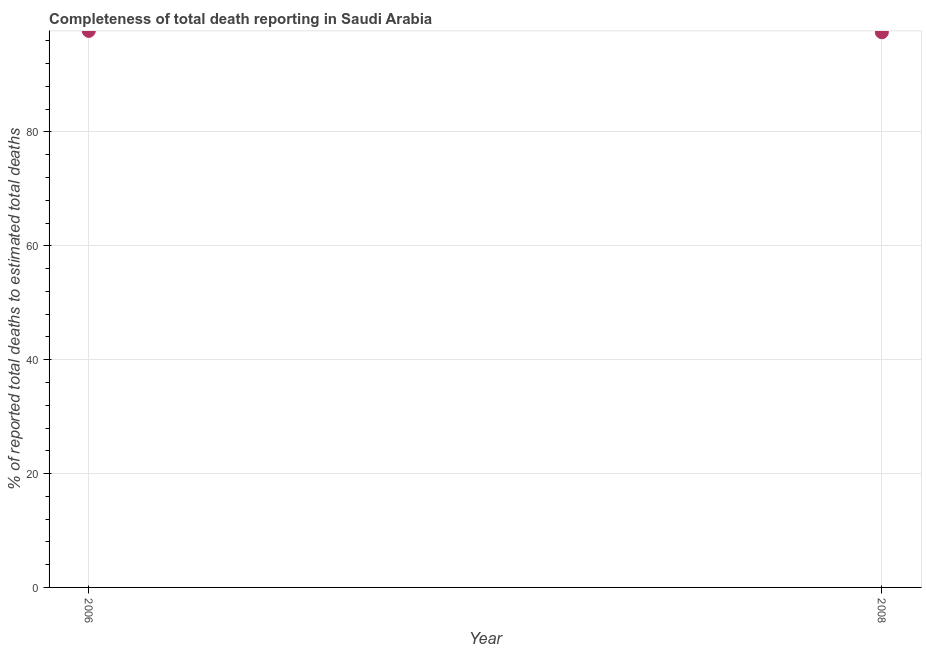What is the completeness of total death reports in 2008?
Offer a very short reply. 97.52. Across all years, what is the maximum completeness of total death reports?
Offer a terse response. 97.76. Across all years, what is the minimum completeness of total death reports?
Provide a succinct answer. 97.52. In which year was the completeness of total death reports maximum?
Your response must be concise. 2006. What is the sum of the completeness of total death reports?
Ensure brevity in your answer.  195.28. What is the difference between the completeness of total death reports in 2006 and 2008?
Ensure brevity in your answer.  0.24. What is the average completeness of total death reports per year?
Make the answer very short. 97.64. What is the median completeness of total death reports?
Your response must be concise. 97.64. What is the ratio of the completeness of total death reports in 2006 to that in 2008?
Make the answer very short. 1. Is the completeness of total death reports in 2006 less than that in 2008?
Make the answer very short. No. In how many years, is the completeness of total death reports greater than the average completeness of total death reports taken over all years?
Your answer should be very brief. 1. Does the completeness of total death reports monotonically increase over the years?
Make the answer very short. No. How many dotlines are there?
Your response must be concise. 1. How many years are there in the graph?
Offer a terse response. 2. What is the difference between two consecutive major ticks on the Y-axis?
Provide a short and direct response. 20. Are the values on the major ticks of Y-axis written in scientific E-notation?
Offer a very short reply. No. Does the graph contain any zero values?
Your answer should be very brief. No. What is the title of the graph?
Offer a very short reply. Completeness of total death reporting in Saudi Arabia. What is the label or title of the X-axis?
Offer a very short reply. Year. What is the label or title of the Y-axis?
Offer a very short reply. % of reported total deaths to estimated total deaths. What is the % of reported total deaths to estimated total deaths in 2006?
Ensure brevity in your answer.  97.76. What is the % of reported total deaths to estimated total deaths in 2008?
Make the answer very short. 97.52. What is the difference between the % of reported total deaths to estimated total deaths in 2006 and 2008?
Offer a very short reply. 0.24. 